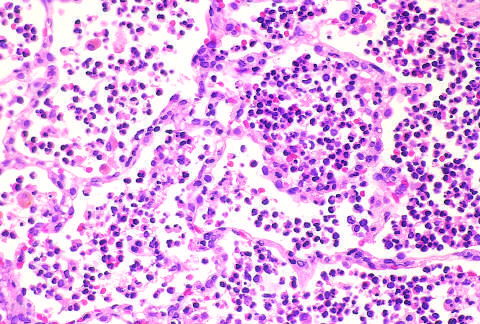what have not yet formed?
Answer the question using a single word or phrase. Fibrin nets 